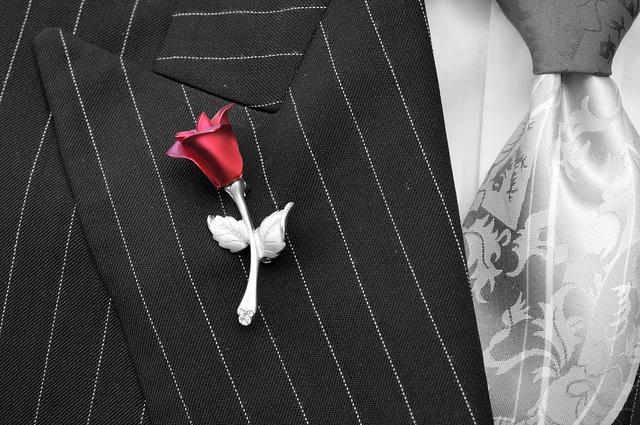What type of suit is this?
Concise answer only. Pinstripe. What color is the flower?
Quick response, please. Red. What is that flowers name?
Short answer required. Rose. 